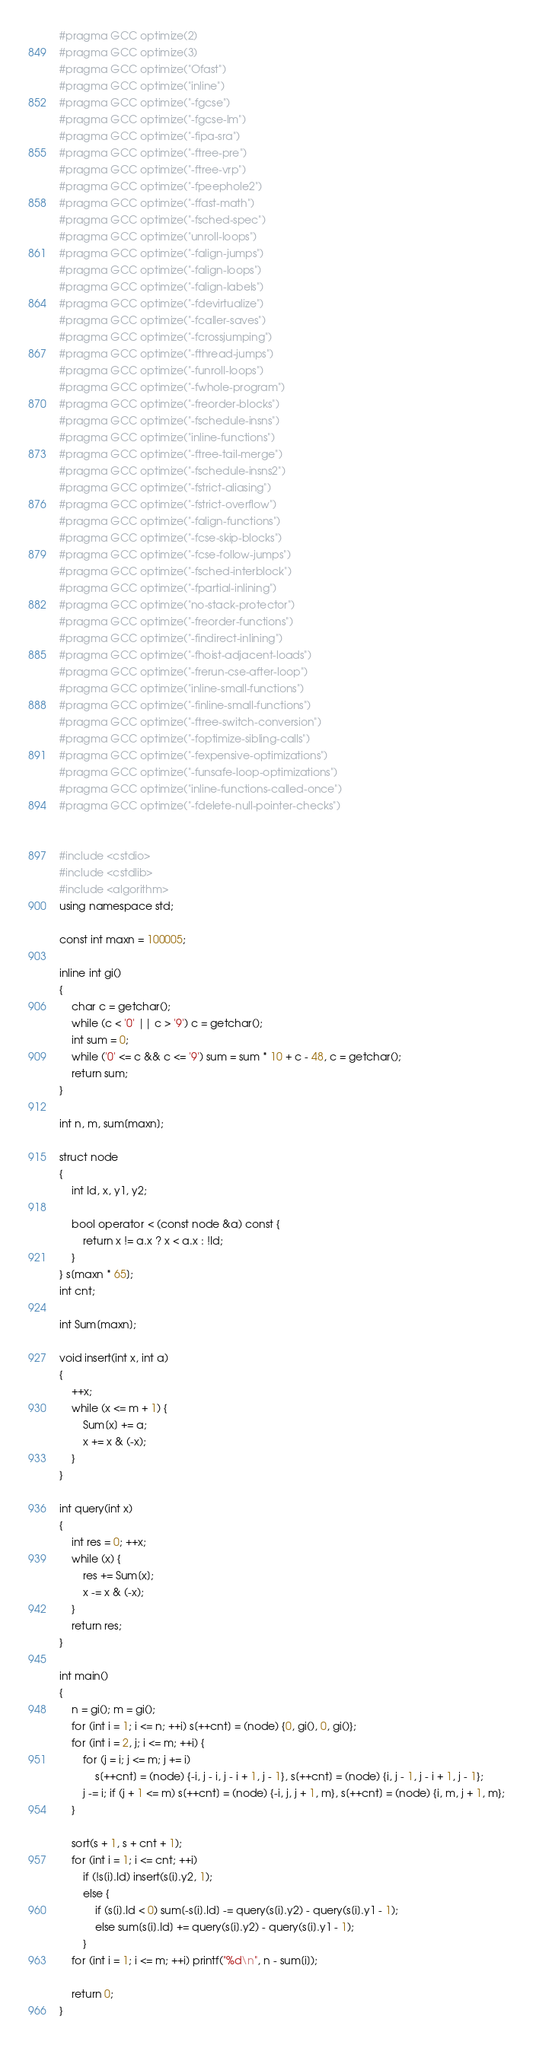Convert code to text. <code><loc_0><loc_0><loc_500><loc_500><_C++_>#pragma GCC optimize(2)
#pragma GCC optimize(3)
#pragma GCC optimize("Ofast")
#pragma GCC optimize("inline")
#pragma GCC optimize("-fgcse")
#pragma GCC optimize("-fgcse-lm")
#pragma GCC optimize("-fipa-sra")
#pragma GCC optimize("-ftree-pre")
#pragma GCC optimize("-ftree-vrp")
#pragma GCC optimize("-fpeephole2")
#pragma GCC optimize("-ffast-math")
#pragma GCC optimize("-fsched-spec")
#pragma GCC optimize("unroll-loops")
#pragma GCC optimize("-falign-jumps")
#pragma GCC optimize("-falign-loops")
#pragma GCC optimize("-falign-labels")
#pragma GCC optimize("-fdevirtualize")
#pragma GCC optimize("-fcaller-saves")
#pragma GCC optimize("-fcrossjumping")
#pragma GCC optimize("-fthread-jumps")
#pragma GCC optimize("-funroll-loops")
#pragma GCC optimize("-fwhole-program")
#pragma GCC optimize("-freorder-blocks")
#pragma GCC optimize("-fschedule-insns")
#pragma GCC optimize("inline-functions")
#pragma GCC optimize("-ftree-tail-merge")
#pragma GCC optimize("-fschedule-insns2")
#pragma GCC optimize("-fstrict-aliasing")
#pragma GCC optimize("-fstrict-overflow")
#pragma GCC optimize("-falign-functions")
#pragma GCC optimize("-fcse-skip-blocks")
#pragma GCC optimize("-fcse-follow-jumps")
#pragma GCC optimize("-fsched-interblock")
#pragma GCC optimize("-fpartial-inlining")
#pragma GCC optimize("no-stack-protector")
#pragma GCC optimize("-freorder-functions")
#pragma GCC optimize("-findirect-inlining")
#pragma GCC optimize("-fhoist-adjacent-loads")
#pragma GCC optimize("-frerun-cse-after-loop")
#pragma GCC optimize("inline-small-functions")
#pragma GCC optimize("-finline-small-functions")
#pragma GCC optimize("-ftree-switch-conversion")
#pragma GCC optimize("-foptimize-sibling-calls")
#pragma GCC optimize("-fexpensive-optimizations")
#pragma GCC optimize("-funsafe-loop-optimizations")
#pragma GCC optimize("inline-functions-called-once")
#pragma GCC optimize("-fdelete-null-pointer-checks")


#include <cstdio>
#include <cstdlib>
#include <algorithm>
using namespace std;
 
const int maxn = 100005;
 
inline int gi()
{
	char c = getchar();
	while (c < '0' || c > '9') c = getchar();
	int sum = 0;
	while ('0' <= c && c <= '9') sum = sum * 10 + c - 48, c = getchar();
	return sum;
}
 
int n, m, sum[maxn];
 
struct node
{
	int Id, x, y1, y2;
 
	bool operator < (const node &a) const {
		return x != a.x ? x < a.x : !Id;
	}
} s[maxn * 65];
int cnt;
 
int Sum[maxn];
 
void insert(int x, int a)
{
	++x;
	while (x <= m + 1) {
		Sum[x] += a;
		x += x & (-x);
	}
}
 
int query(int x)
{
	int res = 0; ++x;
	while (x) {
		res += Sum[x];
		x -= x & (-x);
	}
	return res;
}
 
int main()
{
	n = gi(); m = gi();
	for (int i = 1; i <= n; ++i) s[++cnt] = (node) {0, gi(), 0, gi()};
	for (int i = 2, j; i <= m; ++i) {
		for (j = i; j <= m; j += i)
			s[++cnt] = (node) {-i, j - i, j - i + 1, j - 1}, s[++cnt] = (node) {i, j - 1, j - i + 1, j - 1};
		j -= i; if (j + 1 <= m) s[++cnt] = (node) {-i, j, j + 1, m}, s[++cnt] = (node) {i, m, j + 1, m};
	}

	sort(s + 1, s + cnt + 1);
	for (int i = 1; i <= cnt; ++i)
		if (!s[i].Id) insert(s[i].y2, 1);
		else {
			if (s[i].Id < 0) sum[-s[i].Id] -= query(s[i].y2) - query(s[i].y1 - 1);
			else sum[s[i].Id] += query(s[i].y2) - query(s[i].y1 - 1);
		}
	for (int i = 1; i <= m; ++i) printf("%d\n", n - sum[i]);
	
	return 0;
}
</code> 